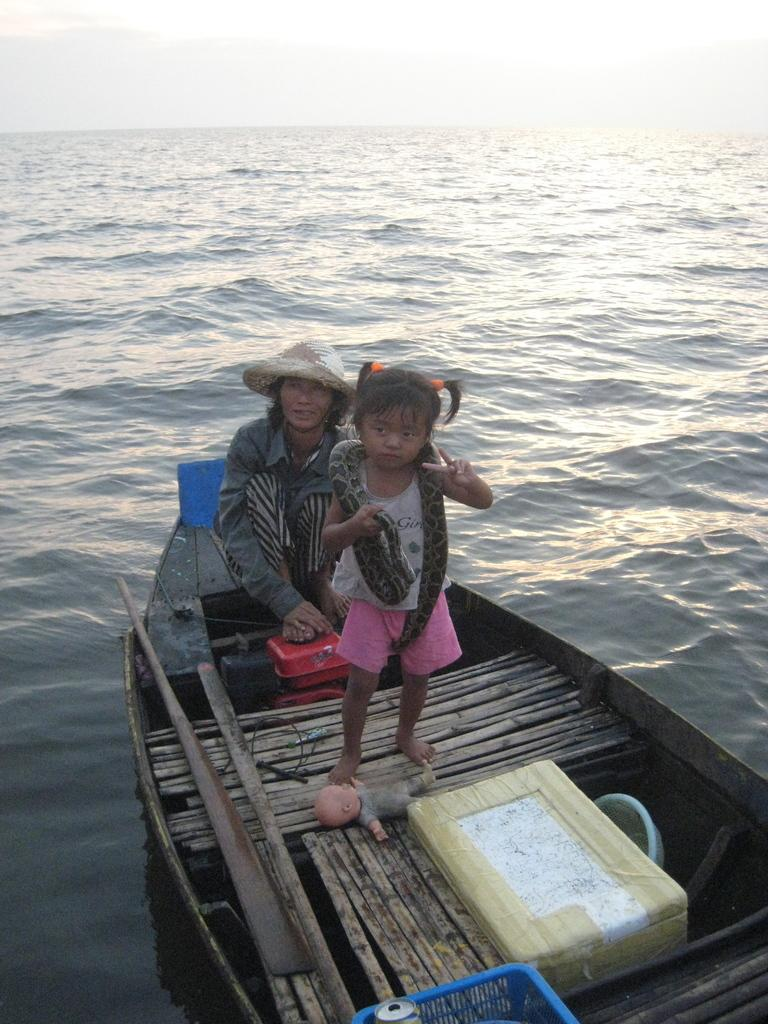Who is present in the boat in the image? There is a woman and a kid in the boat in the image. What is the kid holding in her hands? The kid is holding a snake in her hands. What else can be seen in the boat besides the woman and the kid? There are objects in the boat. What type of water body is visible in the image? There is an ocean visible in the image. What is visible at the top of the image? The sky is visible at the top of the image. Who is the porter assisting in the image? There is no porter present in the image. What type of competition is taking place in the image? There is no competition present in the image. 